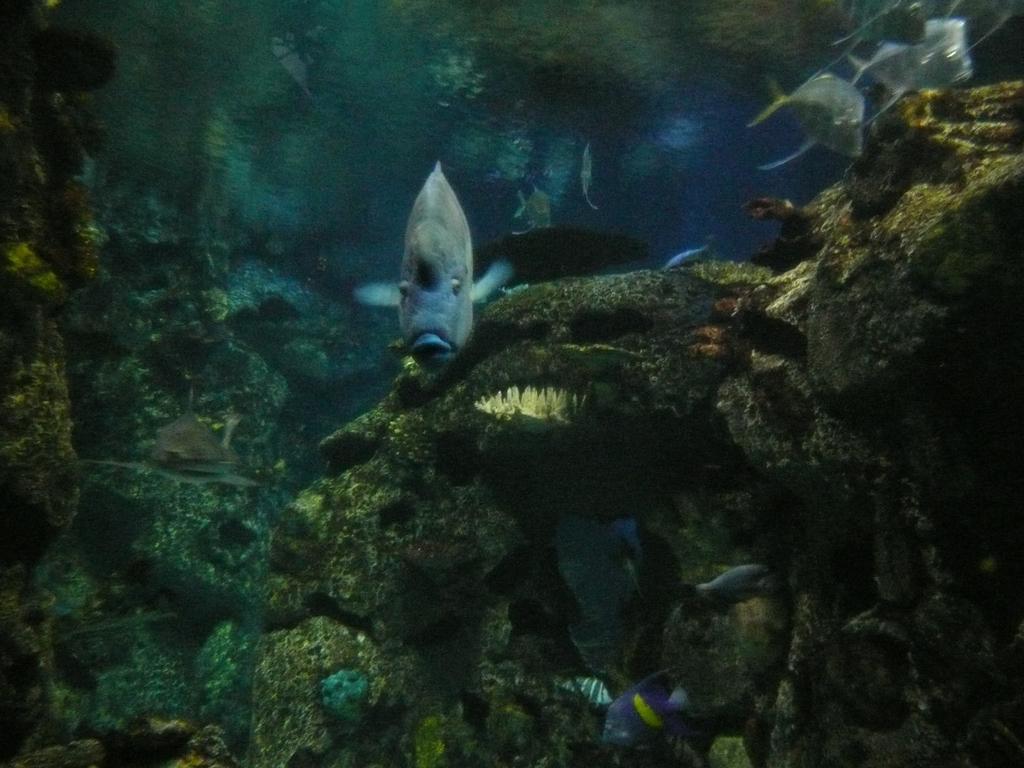Could you give a brief overview of what you see in this image? In this image we can see the fishes in the water, there are water plants. 